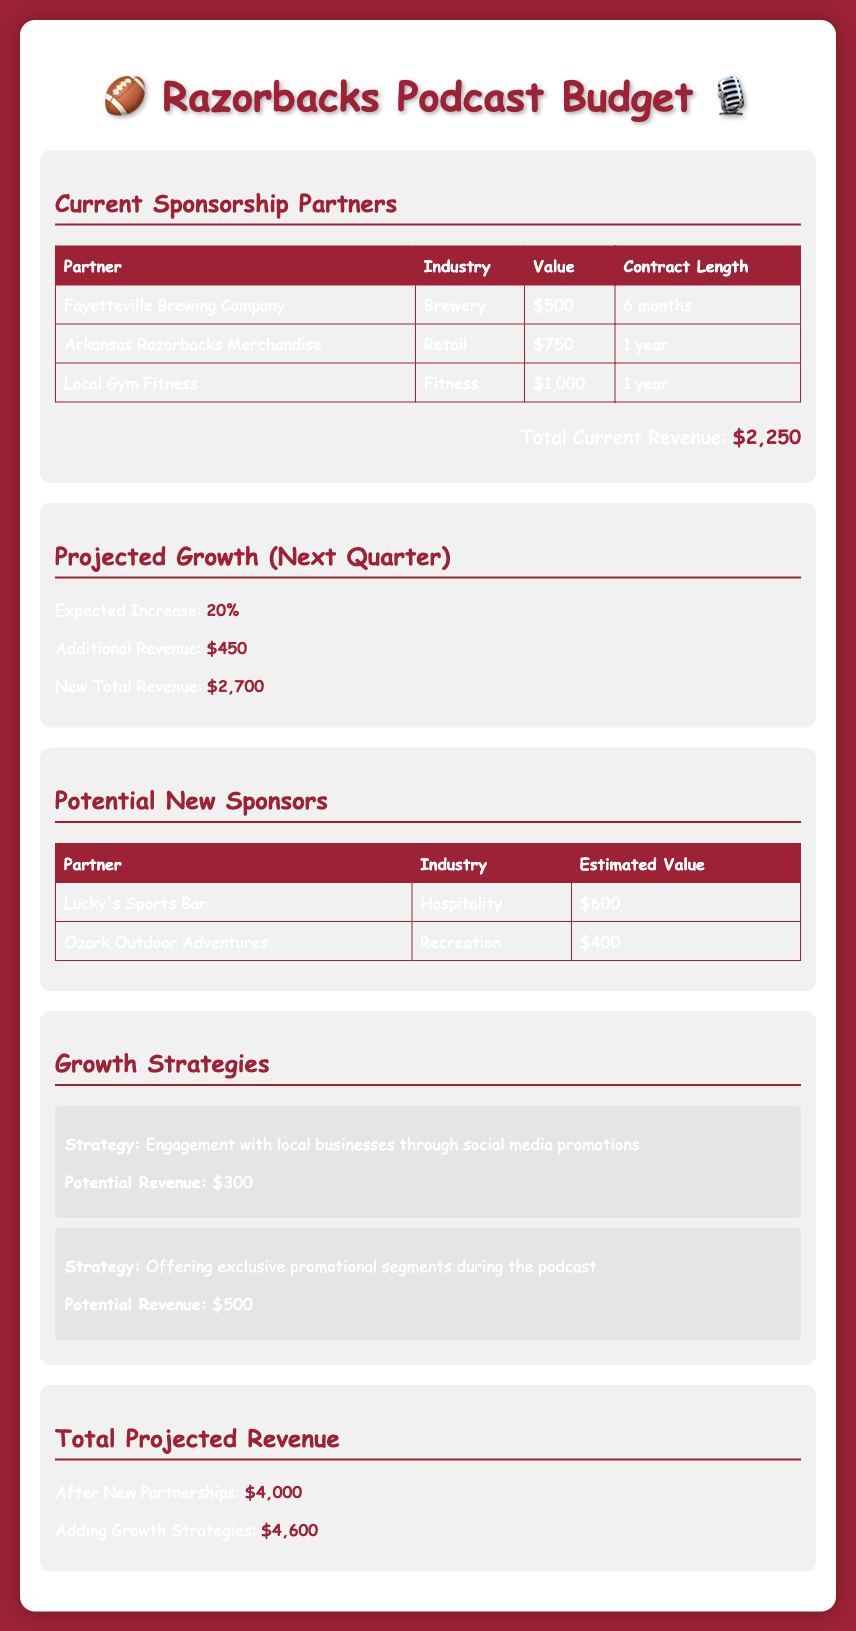What is the total current revenue? The total current revenue is listed in the document as the sum of the values of the current sponsors, which totals $2,250.
Answer: $2,250 What is the expected increase in revenue for the next quarter? The document states that the expected increase is 20%.
Answer: 20% What is the estimated value of Lucky's Sports Bar? The document lists Lucky's Sports Bar with an estimated value of $600 under potential new sponsors.
Answer: $600 How long is the contract with Arkansas Razorbacks Merchandise? The document indicates that the contract length with Arkansas Razorbacks Merchandise is for 1 year.
Answer: 1 year What is the potential revenue from social media promotions? The document identifies the potential revenue from engaging with local businesses through social media promotions as $300.
Answer: $300 What will be the new total revenue after the projected growth? The new total revenue after the expected increase of $450 is stated to be $2,700.
Answer: $2,700 What is the total projected revenue after new partnerships? The document states the total projected revenue after new partnerships is $4,000.
Answer: $4,000 How much additional revenue will come from growth strategies? The document notes that after adding growth strategies, the revenue increases to $4,600.
Answer: $4,600 What industry does Local Gym Fitness belong to? According to the document, Local Gym Fitness is classified under the Fitness industry.
Answer: Fitness 